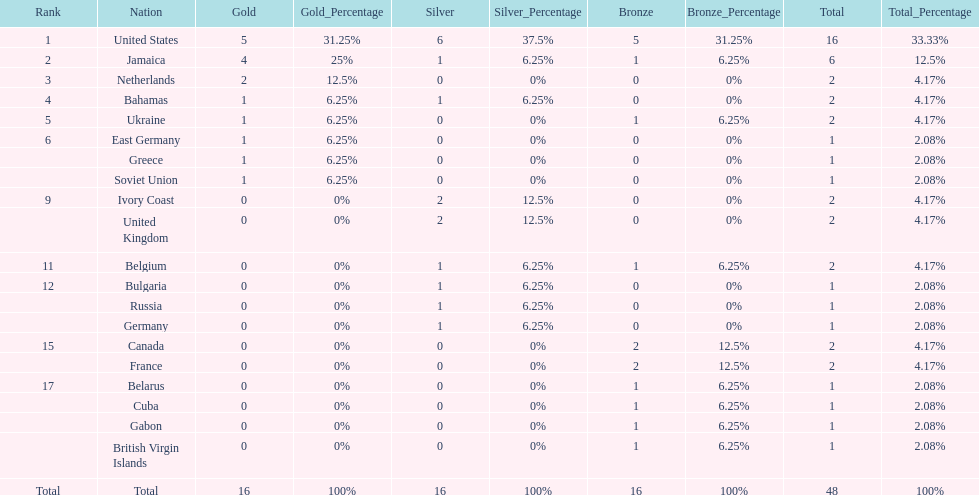How many nations won at least two gold medals? 3. Help me parse the entirety of this table. {'header': ['Rank', 'Nation', 'Gold', 'Gold_Percentage', 'Silver', 'Silver_Percentage', 'Bronze', 'Bronze_Percentage', 'Total', 'Total_Percentage'], 'rows': [['1', 'United States', '5', '31.25%', '6', '37.5%', '5', '31.25%', '16', '33.33%'], ['2', 'Jamaica', '4', '25%', '1', '6.25%', '1', '6.25%', '6', '12.5%'], ['3', 'Netherlands', '2', '12.5%', '0', '0%', '0', '0%', '2', '4.17%'], ['4', 'Bahamas', '1', '6.25%', '1', '6.25%', '0', '0%', '2', '4.17%'], ['5', 'Ukraine', '1', '6.25%', '0', '0%', '1', '6.25%', '2', '4.17%'], ['6', 'East Germany', '1', '6.25%', '0', '0%', '0', '0%', '1', '2.08%'], ['', 'Greece', '1', '6.25%', '0', '0%', '0', '0%', '1', '2.08%'], ['', 'Soviet Union', '1', '6.25%', '0', '0%', '0', '0%', '1', '2.08%'], ['9', 'Ivory Coast', '0', '0%', '2', '12.5%', '0', '0%', '2', '4.17%'], ['', 'United Kingdom', '0', '0%', '2', '12.5%', '0', '0%', '2', '4.17%'], ['11', 'Belgium', '0', '0%', '1', '6.25%', '1', '6.25%', '2', '4.17%'], ['12', 'Bulgaria', '0', '0%', '1', '6.25%', '0', '0%', '1', '2.08%'], ['', 'Russia', '0', '0%', '1', '6.25%', '0', '0%', '1', '2.08%'], ['', 'Germany', '0', '0%', '1', '6.25%', '0', '0%', '1', '2.08%'], ['15', 'Canada', '0', '0%', '0', '0%', '2', '12.5%', '2', '4.17%'], ['', 'France', '0', '0%', '0', '0%', '2', '12.5%', '2', '4.17%'], ['17', 'Belarus', '0', '0%', '0', '0%', '1', '6.25%', '1', '2.08%'], ['', 'Cuba', '0', '0%', '0', '0%', '1', '6.25%', '1', '2.08%'], ['', 'Gabon', '0', '0%', '0', '0%', '1', '6.25%', '1', '2.08%'], ['', 'British Virgin Islands', '0', '0%', '0', '0%', '1', '6.25%', '1', '2.08%'], ['Total', 'Total', '16', '100%', '16', '100%', '16', '100%', '48', '100%']]} 